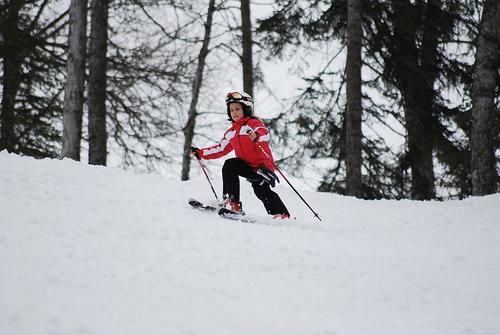Are the glasses over the boy's eyes?
Quick response, please. No. What color pole is the skier by?
Write a very short answer. Red. Is the child standing?
Quick response, please. Yes. What is the boy doing?
Answer briefly. Skiing. What is the boy holding?
Answer briefly. Ski poles. What is the man standing in between?
Quick response, please. Trees. Is the skier going to fall?
Answer briefly. No. Is he hurt?
Concise answer only. No. 